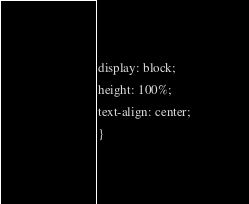Convert code to text. <code><loc_0><loc_0><loc_500><loc_500><_CSS_>display: block;
height: 100%;
text-align: center;
}</code> 